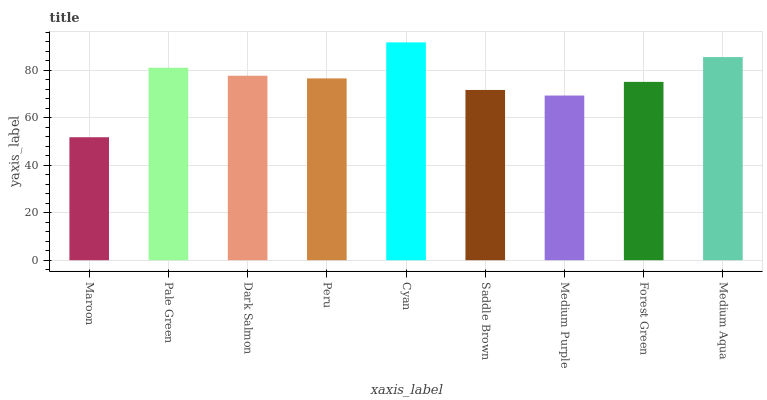Is Pale Green the minimum?
Answer yes or no. No. Is Pale Green the maximum?
Answer yes or no. No. Is Pale Green greater than Maroon?
Answer yes or no. Yes. Is Maroon less than Pale Green?
Answer yes or no. Yes. Is Maroon greater than Pale Green?
Answer yes or no. No. Is Pale Green less than Maroon?
Answer yes or no. No. Is Peru the high median?
Answer yes or no. Yes. Is Peru the low median?
Answer yes or no. Yes. Is Medium Purple the high median?
Answer yes or no. No. Is Maroon the low median?
Answer yes or no. No. 